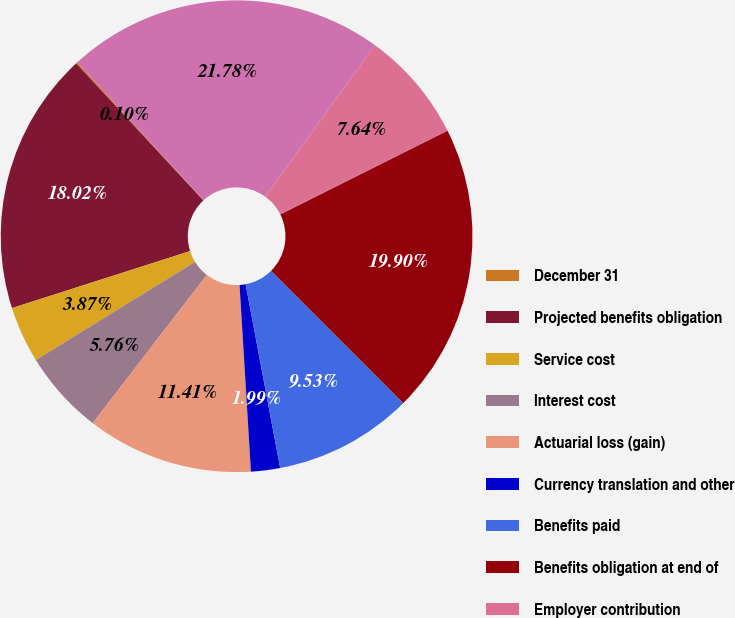Convert chart. <chart><loc_0><loc_0><loc_500><loc_500><pie_chart><fcel>December 31<fcel>Projected benefits obligation<fcel>Service cost<fcel>Interest cost<fcel>Actuarial loss (gain)<fcel>Currency translation and other<fcel>Benefits paid<fcel>Benefits obligation at end of<fcel>Employer contribution<fcel>Funded status at end of year<nl><fcel>0.1%<fcel>18.02%<fcel>3.87%<fcel>5.76%<fcel>11.41%<fcel>1.99%<fcel>9.53%<fcel>19.9%<fcel>7.64%<fcel>21.78%<nl></chart> 